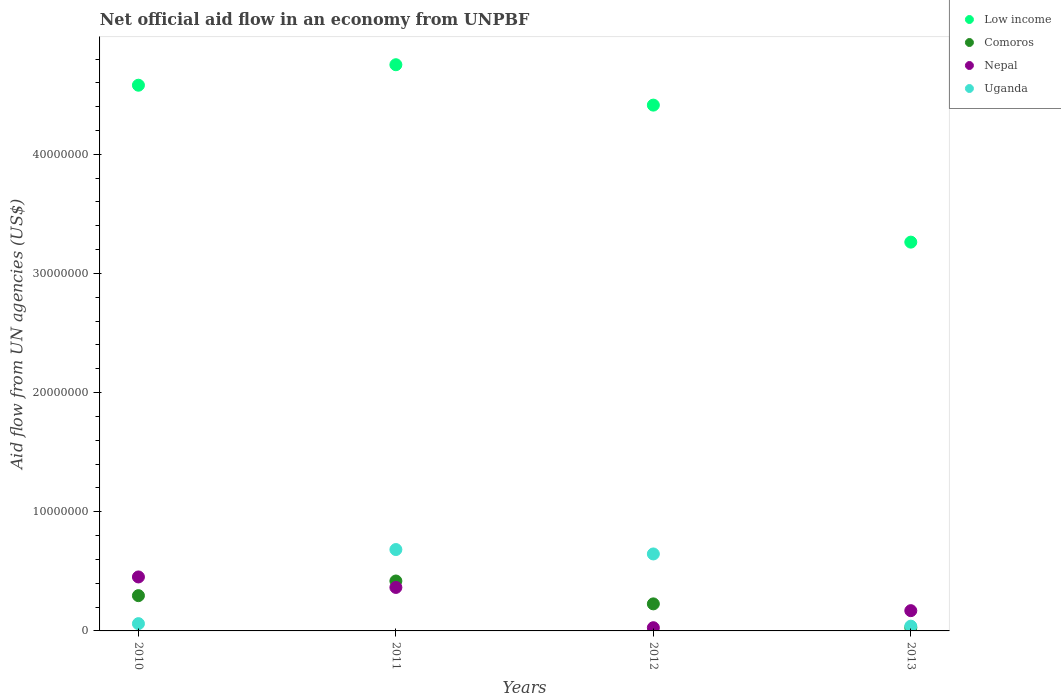What is the net official aid flow in Nepal in 2012?
Your response must be concise. 2.70e+05. Across all years, what is the maximum net official aid flow in Low income?
Provide a short and direct response. 4.75e+07. Across all years, what is the minimum net official aid flow in Comoros?
Make the answer very short. 2.70e+05. In which year was the net official aid flow in Low income maximum?
Give a very brief answer. 2011. What is the total net official aid flow in Nepal in the graph?
Make the answer very short. 1.02e+07. What is the difference between the net official aid flow in Uganda in 2012 and that in 2013?
Your answer should be very brief. 6.06e+06. What is the difference between the net official aid flow in Low income in 2013 and the net official aid flow in Comoros in 2012?
Give a very brief answer. 3.04e+07. What is the average net official aid flow in Uganda per year?
Your response must be concise. 3.58e+06. In the year 2013, what is the difference between the net official aid flow in Nepal and net official aid flow in Uganda?
Give a very brief answer. 1.30e+06. In how many years, is the net official aid flow in Nepal greater than 36000000 US$?
Your answer should be very brief. 0. What is the ratio of the net official aid flow in Comoros in 2010 to that in 2012?
Ensure brevity in your answer.  1.3. What is the difference between the highest and the second highest net official aid flow in Low income?
Offer a very short reply. 1.72e+06. What is the difference between the highest and the lowest net official aid flow in Comoros?
Keep it short and to the point. 3.92e+06. In how many years, is the net official aid flow in Uganda greater than the average net official aid flow in Uganda taken over all years?
Offer a very short reply. 2. Is the sum of the net official aid flow in Comoros in 2012 and 2013 greater than the maximum net official aid flow in Low income across all years?
Provide a succinct answer. No. Is the net official aid flow in Uganda strictly less than the net official aid flow in Comoros over the years?
Offer a very short reply. No. Does the graph contain grids?
Your answer should be compact. No. Where does the legend appear in the graph?
Your answer should be compact. Top right. How many legend labels are there?
Offer a terse response. 4. What is the title of the graph?
Provide a succinct answer. Net official aid flow in an economy from UNPBF. What is the label or title of the Y-axis?
Your answer should be compact. Aid flow from UN agencies (US$). What is the Aid flow from UN agencies (US$) of Low income in 2010?
Provide a short and direct response. 4.58e+07. What is the Aid flow from UN agencies (US$) in Comoros in 2010?
Your answer should be very brief. 2.96e+06. What is the Aid flow from UN agencies (US$) in Nepal in 2010?
Make the answer very short. 4.53e+06. What is the Aid flow from UN agencies (US$) of Low income in 2011?
Your response must be concise. 4.75e+07. What is the Aid flow from UN agencies (US$) of Comoros in 2011?
Your response must be concise. 4.19e+06. What is the Aid flow from UN agencies (US$) of Nepal in 2011?
Make the answer very short. 3.65e+06. What is the Aid flow from UN agencies (US$) of Uganda in 2011?
Provide a succinct answer. 6.83e+06. What is the Aid flow from UN agencies (US$) in Low income in 2012?
Give a very brief answer. 4.41e+07. What is the Aid flow from UN agencies (US$) in Comoros in 2012?
Your response must be concise. 2.27e+06. What is the Aid flow from UN agencies (US$) of Nepal in 2012?
Provide a succinct answer. 2.70e+05. What is the Aid flow from UN agencies (US$) of Uganda in 2012?
Offer a very short reply. 6.46e+06. What is the Aid flow from UN agencies (US$) of Low income in 2013?
Give a very brief answer. 3.26e+07. What is the Aid flow from UN agencies (US$) in Nepal in 2013?
Your answer should be compact. 1.70e+06. Across all years, what is the maximum Aid flow from UN agencies (US$) in Low income?
Offer a very short reply. 4.75e+07. Across all years, what is the maximum Aid flow from UN agencies (US$) in Comoros?
Provide a short and direct response. 4.19e+06. Across all years, what is the maximum Aid flow from UN agencies (US$) in Nepal?
Your answer should be compact. 4.53e+06. Across all years, what is the maximum Aid flow from UN agencies (US$) of Uganda?
Provide a succinct answer. 6.83e+06. Across all years, what is the minimum Aid flow from UN agencies (US$) in Low income?
Your response must be concise. 3.26e+07. Across all years, what is the minimum Aid flow from UN agencies (US$) of Uganda?
Make the answer very short. 4.00e+05. What is the total Aid flow from UN agencies (US$) of Low income in the graph?
Offer a terse response. 1.70e+08. What is the total Aid flow from UN agencies (US$) in Comoros in the graph?
Keep it short and to the point. 9.69e+06. What is the total Aid flow from UN agencies (US$) of Nepal in the graph?
Offer a very short reply. 1.02e+07. What is the total Aid flow from UN agencies (US$) of Uganda in the graph?
Your answer should be compact. 1.43e+07. What is the difference between the Aid flow from UN agencies (US$) in Low income in 2010 and that in 2011?
Ensure brevity in your answer.  -1.72e+06. What is the difference between the Aid flow from UN agencies (US$) in Comoros in 2010 and that in 2011?
Your response must be concise. -1.23e+06. What is the difference between the Aid flow from UN agencies (US$) of Nepal in 2010 and that in 2011?
Your answer should be compact. 8.80e+05. What is the difference between the Aid flow from UN agencies (US$) in Uganda in 2010 and that in 2011?
Provide a succinct answer. -6.22e+06. What is the difference between the Aid flow from UN agencies (US$) in Low income in 2010 and that in 2012?
Offer a very short reply. 1.67e+06. What is the difference between the Aid flow from UN agencies (US$) of Comoros in 2010 and that in 2012?
Provide a succinct answer. 6.90e+05. What is the difference between the Aid flow from UN agencies (US$) in Nepal in 2010 and that in 2012?
Your answer should be compact. 4.26e+06. What is the difference between the Aid flow from UN agencies (US$) of Uganda in 2010 and that in 2012?
Provide a succinct answer. -5.85e+06. What is the difference between the Aid flow from UN agencies (US$) in Low income in 2010 and that in 2013?
Keep it short and to the point. 1.32e+07. What is the difference between the Aid flow from UN agencies (US$) in Comoros in 2010 and that in 2013?
Keep it short and to the point. 2.69e+06. What is the difference between the Aid flow from UN agencies (US$) of Nepal in 2010 and that in 2013?
Make the answer very short. 2.83e+06. What is the difference between the Aid flow from UN agencies (US$) in Low income in 2011 and that in 2012?
Offer a very short reply. 3.39e+06. What is the difference between the Aid flow from UN agencies (US$) of Comoros in 2011 and that in 2012?
Offer a terse response. 1.92e+06. What is the difference between the Aid flow from UN agencies (US$) in Nepal in 2011 and that in 2012?
Give a very brief answer. 3.38e+06. What is the difference between the Aid flow from UN agencies (US$) in Uganda in 2011 and that in 2012?
Give a very brief answer. 3.70e+05. What is the difference between the Aid flow from UN agencies (US$) in Low income in 2011 and that in 2013?
Your answer should be compact. 1.49e+07. What is the difference between the Aid flow from UN agencies (US$) of Comoros in 2011 and that in 2013?
Offer a terse response. 3.92e+06. What is the difference between the Aid flow from UN agencies (US$) in Nepal in 2011 and that in 2013?
Make the answer very short. 1.95e+06. What is the difference between the Aid flow from UN agencies (US$) in Uganda in 2011 and that in 2013?
Keep it short and to the point. 6.43e+06. What is the difference between the Aid flow from UN agencies (US$) of Low income in 2012 and that in 2013?
Ensure brevity in your answer.  1.15e+07. What is the difference between the Aid flow from UN agencies (US$) of Nepal in 2012 and that in 2013?
Provide a short and direct response. -1.43e+06. What is the difference between the Aid flow from UN agencies (US$) of Uganda in 2012 and that in 2013?
Your response must be concise. 6.06e+06. What is the difference between the Aid flow from UN agencies (US$) in Low income in 2010 and the Aid flow from UN agencies (US$) in Comoros in 2011?
Your answer should be compact. 4.16e+07. What is the difference between the Aid flow from UN agencies (US$) in Low income in 2010 and the Aid flow from UN agencies (US$) in Nepal in 2011?
Provide a succinct answer. 4.22e+07. What is the difference between the Aid flow from UN agencies (US$) of Low income in 2010 and the Aid flow from UN agencies (US$) of Uganda in 2011?
Offer a terse response. 3.90e+07. What is the difference between the Aid flow from UN agencies (US$) in Comoros in 2010 and the Aid flow from UN agencies (US$) in Nepal in 2011?
Provide a succinct answer. -6.90e+05. What is the difference between the Aid flow from UN agencies (US$) in Comoros in 2010 and the Aid flow from UN agencies (US$) in Uganda in 2011?
Ensure brevity in your answer.  -3.87e+06. What is the difference between the Aid flow from UN agencies (US$) of Nepal in 2010 and the Aid flow from UN agencies (US$) of Uganda in 2011?
Your response must be concise. -2.30e+06. What is the difference between the Aid flow from UN agencies (US$) in Low income in 2010 and the Aid flow from UN agencies (US$) in Comoros in 2012?
Give a very brief answer. 4.35e+07. What is the difference between the Aid flow from UN agencies (US$) in Low income in 2010 and the Aid flow from UN agencies (US$) in Nepal in 2012?
Ensure brevity in your answer.  4.55e+07. What is the difference between the Aid flow from UN agencies (US$) of Low income in 2010 and the Aid flow from UN agencies (US$) of Uganda in 2012?
Ensure brevity in your answer.  3.93e+07. What is the difference between the Aid flow from UN agencies (US$) of Comoros in 2010 and the Aid flow from UN agencies (US$) of Nepal in 2012?
Your response must be concise. 2.69e+06. What is the difference between the Aid flow from UN agencies (US$) in Comoros in 2010 and the Aid flow from UN agencies (US$) in Uganda in 2012?
Offer a terse response. -3.50e+06. What is the difference between the Aid flow from UN agencies (US$) in Nepal in 2010 and the Aid flow from UN agencies (US$) in Uganda in 2012?
Ensure brevity in your answer.  -1.93e+06. What is the difference between the Aid flow from UN agencies (US$) of Low income in 2010 and the Aid flow from UN agencies (US$) of Comoros in 2013?
Your answer should be compact. 4.55e+07. What is the difference between the Aid flow from UN agencies (US$) of Low income in 2010 and the Aid flow from UN agencies (US$) of Nepal in 2013?
Provide a succinct answer. 4.41e+07. What is the difference between the Aid flow from UN agencies (US$) in Low income in 2010 and the Aid flow from UN agencies (US$) in Uganda in 2013?
Ensure brevity in your answer.  4.54e+07. What is the difference between the Aid flow from UN agencies (US$) in Comoros in 2010 and the Aid flow from UN agencies (US$) in Nepal in 2013?
Your response must be concise. 1.26e+06. What is the difference between the Aid flow from UN agencies (US$) of Comoros in 2010 and the Aid flow from UN agencies (US$) of Uganda in 2013?
Provide a short and direct response. 2.56e+06. What is the difference between the Aid flow from UN agencies (US$) of Nepal in 2010 and the Aid flow from UN agencies (US$) of Uganda in 2013?
Give a very brief answer. 4.13e+06. What is the difference between the Aid flow from UN agencies (US$) of Low income in 2011 and the Aid flow from UN agencies (US$) of Comoros in 2012?
Keep it short and to the point. 4.52e+07. What is the difference between the Aid flow from UN agencies (US$) in Low income in 2011 and the Aid flow from UN agencies (US$) in Nepal in 2012?
Your response must be concise. 4.72e+07. What is the difference between the Aid flow from UN agencies (US$) in Low income in 2011 and the Aid flow from UN agencies (US$) in Uganda in 2012?
Offer a terse response. 4.11e+07. What is the difference between the Aid flow from UN agencies (US$) in Comoros in 2011 and the Aid flow from UN agencies (US$) in Nepal in 2012?
Your answer should be compact. 3.92e+06. What is the difference between the Aid flow from UN agencies (US$) in Comoros in 2011 and the Aid flow from UN agencies (US$) in Uganda in 2012?
Provide a short and direct response. -2.27e+06. What is the difference between the Aid flow from UN agencies (US$) in Nepal in 2011 and the Aid flow from UN agencies (US$) in Uganda in 2012?
Offer a very short reply. -2.81e+06. What is the difference between the Aid flow from UN agencies (US$) in Low income in 2011 and the Aid flow from UN agencies (US$) in Comoros in 2013?
Offer a terse response. 4.72e+07. What is the difference between the Aid flow from UN agencies (US$) in Low income in 2011 and the Aid flow from UN agencies (US$) in Nepal in 2013?
Your answer should be compact. 4.58e+07. What is the difference between the Aid flow from UN agencies (US$) in Low income in 2011 and the Aid flow from UN agencies (US$) in Uganda in 2013?
Provide a succinct answer. 4.71e+07. What is the difference between the Aid flow from UN agencies (US$) of Comoros in 2011 and the Aid flow from UN agencies (US$) of Nepal in 2013?
Your answer should be very brief. 2.49e+06. What is the difference between the Aid flow from UN agencies (US$) of Comoros in 2011 and the Aid flow from UN agencies (US$) of Uganda in 2013?
Offer a terse response. 3.79e+06. What is the difference between the Aid flow from UN agencies (US$) in Nepal in 2011 and the Aid flow from UN agencies (US$) in Uganda in 2013?
Make the answer very short. 3.25e+06. What is the difference between the Aid flow from UN agencies (US$) in Low income in 2012 and the Aid flow from UN agencies (US$) in Comoros in 2013?
Give a very brief answer. 4.39e+07. What is the difference between the Aid flow from UN agencies (US$) of Low income in 2012 and the Aid flow from UN agencies (US$) of Nepal in 2013?
Offer a terse response. 4.24e+07. What is the difference between the Aid flow from UN agencies (US$) of Low income in 2012 and the Aid flow from UN agencies (US$) of Uganda in 2013?
Your answer should be compact. 4.37e+07. What is the difference between the Aid flow from UN agencies (US$) in Comoros in 2012 and the Aid flow from UN agencies (US$) in Nepal in 2013?
Provide a succinct answer. 5.70e+05. What is the difference between the Aid flow from UN agencies (US$) of Comoros in 2012 and the Aid flow from UN agencies (US$) of Uganda in 2013?
Offer a terse response. 1.87e+06. What is the difference between the Aid flow from UN agencies (US$) in Nepal in 2012 and the Aid flow from UN agencies (US$) in Uganda in 2013?
Give a very brief answer. -1.30e+05. What is the average Aid flow from UN agencies (US$) of Low income per year?
Keep it short and to the point. 4.25e+07. What is the average Aid flow from UN agencies (US$) in Comoros per year?
Keep it short and to the point. 2.42e+06. What is the average Aid flow from UN agencies (US$) of Nepal per year?
Your answer should be very brief. 2.54e+06. What is the average Aid flow from UN agencies (US$) of Uganda per year?
Provide a succinct answer. 3.58e+06. In the year 2010, what is the difference between the Aid flow from UN agencies (US$) of Low income and Aid flow from UN agencies (US$) of Comoros?
Provide a succinct answer. 4.28e+07. In the year 2010, what is the difference between the Aid flow from UN agencies (US$) of Low income and Aid flow from UN agencies (US$) of Nepal?
Give a very brief answer. 4.13e+07. In the year 2010, what is the difference between the Aid flow from UN agencies (US$) in Low income and Aid flow from UN agencies (US$) in Uganda?
Give a very brief answer. 4.52e+07. In the year 2010, what is the difference between the Aid flow from UN agencies (US$) of Comoros and Aid flow from UN agencies (US$) of Nepal?
Your response must be concise. -1.57e+06. In the year 2010, what is the difference between the Aid flow from UN agencies (US$) of Comoros and Aid flow from UN agencies (US$) of Uganda?
Your answer should be very brief. 2.35e+06. In the year 2010, what is the difference between the Aid flow from UN agencies (US$) of Nepal and Aid flow from UN agencies (US$) of Uganda?
Provide a succinct answer. 3.92e+06. In the year 2011, what is the difference between the Aid flow from UN agencies (US$) of Low income and Aid flow from UN agencies (US$) of Comoros?
Keep it short and to the point. 4.33e+07. In the year 2011, what is the difference between the Aid flow from UN agencies (US$) in Low income and Aid flow from UN agencies (US$) in Nepal?
Offer a very short reply. 4.39e+07. In the year 2011, what is the difference between the Aid flow from UN agencies (US$) of Low income and Aid flow from UN agencies (US$) of Uganda?
Your answer should be very brief. 4.07e+07. In the year 2011, what is the difference between the Aid flow from UN agencies (US$) in Comoros and Aid flow from UN agencies (US$) in Nepal?
Give a very brief answer. 5.40e+05. In the year 2011, what is the difference between the Aid flow from UN agencies (US$) of Comoros and Aid flow from UN agencies (US$) of Uganda?
Make the answer very short. -2.64e+06. In the year 2011, what is the difference between the Aid flow from UN agencies (US$) in Nepal and Aid flow from UN agencies (US$) in Uganda?
Provide a short and direct response. -3.18e+06. In the year 2012, what is the difference between the Aid flow from UN agencies (US$) in Low income and Aid flow from UN agencies (US$) in Comoros?
Keep it short and to the point. 4.19e+07. In the year 2012, what is the difference between the Aid flow from UN agencies (US$) in Low income and Aid flow from UN agencies (US$) in Nepal?
Keep it short and to the point. 4.39e+07. In the year 2012, what is the difference between the Aid flow from UN agencies (US$) in Low income and Aid flow from UN agencies (US$) in Uganda?
Give a very brief answer. 3.77e+07. In the year 2012, what is the difference between the Aid flow from UN agencies (US$) in Comoros and Aid flow from UN agencies (US$) in Uganda?
Ensure brevity in your answer.  -4.19e+06. In the year 2012, what is the difference between the Aid flow from UN agencies (US$) of Nepal and Aid flow from UN agencies (US$) of Uganda?
Your response must be concise. -6.19e+06. In the year 2013, what is the difference between the Aid flow from UN agencies (US$) in Low income and Aid flow from UN agencies (US$) in Comoros?
Offer a very short reply. 3.24e+07. In the year 2013, what is the difference between the Aid flow from UN agencies (US$) of Low income and Aid flow from UN agencies (US$) of Nepal?
Your answer should be compact. 3.09e+07. In the year 2013, what is the difference between the Aid flow from UN agencies (US$) in Low income and Aid flow from UN agencies (US$) in Uganda?
Ensure brevity in your answer.  3.22e+07. In the year 2013, what is the difference between the Aid flow from UN agencies (US$) in Comoros and Aid flow from UN agencies (US$) in Nepal?
Your answer should be compact. -1.43e+06. In the year 2013, what is the difference between the Aid flow from UN agencies (US$) of Nepal and Aid flow from UN agencies (US$) of Uganda?
Your response must be concise. 1.30e+06. What is the ratio of the Aid flow from UN agencies (US$) in Low income in 2010 to that in 2011?
Keep it short and to the point. 0.96. What is the ratio of the Aid flow from UN agencies (US$) of Comoros in 2010 to that in 2011?
Keep it short and to the point. 0.71. What is the ratio of the Aid flow from UN agencies (US$) in Nepal in 2010 to that in 2011?
Provide a succinct answer. 1.24. What is the ratio of the Aid flow from UN agencies (US$) in Uganda in 2010 to that in 2011?
Your answer should be very brief. 0.09. What is the ratio of the Aid flow from UN agencies (US$) in Low income in 2010 to that in 2012?
Make the answer very short. 1.04. What is the ratio of the Aid flow from UN agencies (US$) in Comoros in 2010 to that in 2012?
Provide a succinct answer. 1.3. What is the ratio of the Aid flow from UN agencies (US$) of Nepal in 2010 to that in 2012?
Provide a succinct answer. 16.78. What is the ratio of the Aid flow from UN agencies (US$) of Uganda in 2010 to that in 2012?
Your answer should be compact. 0.09. What is the ratio of the Aid flow from UN agencies (US$) of Low income in 2010 to that in 2013?
Make the answer very short. 1.4. What is the ratio of the Aid flow from UN agencies (US$) in Comoros in 2010 to that in 2013?
Your response must be concise. 10.96. What is the ratio of the Aid flow from UN agencies (US$) of Nepal in 2010 to that in 2013?
Offer a very short reply. 2.66. What is the ratio of the Aid flow from UN agencies (US$) in Uganda in 2010 to that in 2013?
Give a very brief answer. 1.52. What is the ratio of the Aid flow from UN agencies (US$) of Low income in 2011 to that in 2012?
Provide a succinct answer. 1.08. What is the ratio of the Aid flow from UN agencies (US$) in Comoros in 2011 to that in 2012?
Provide a succinct answer. 1.85. What is the ratio of the Aid flow from UN agencies (US$) of Nepal in 2011 to that in 2012?
Provide a succinct answer. 13.52. What is the ratio of the Aid flow from UN agencies (US$) of Uganda in 2011 to that in 2012?
Offer a very short reply. 1.06. What is the ratio of the Aid flow from UN agencies (US$) of Low income in 2011 to that in 2013?
Keep it short and to the point. 1.46. What is the ratio of the Aid flow from UN agencies (US$) in Comoros in 2011 to that in 2013?
Your answer should be very brief. 15.52. What is the ratio of the Aid flow from UN agencies (US$) in Nepal in 2011 to that in 2013?
Your answer should be compact. 2.15. What is the ratio of the Aid flow from UN agencies (US$) in Uganda in 2011 to that in 2013?
Provide a short and direct response. 17.07. What is the ratio of the Aid flow from UN agencies (US$) in Low income in 2012 to that in 2013?
Your answer should be very brief. 1.35. What is the ratio of the Aid flow from UN agencies (US$) in Comoros in 2012 to that in 2013?
Make the answer very short. 8.41. What is the ratio of the Aid flow from UN agencies (US$) in Nepal in 2012 to that in 2013?
Your answer should be compact. 0.16. What is the ratio of the Aid flow from UN agencies (US$) of Uganda in 2012 to that in 2013?
Offer a terse response. 16.15. What is the difference between the highest and the second highest Aid flow from UN agencies (US$) in Low income?
Make the answer very short. 1.72e+06. What is the difference between the highest and the second highest Aid flow from UN agencies (US$) of Comoros?
Your response must be concise. 1.23e+06. What is the difference between the highest and the second highest Aid flow from UN agencies (US$) in Nepal?
Ensure brevity in your answer.  8.80e+05. What is the difference between the highest and the lowest Aid flow from UN agencies (US$) in Low income?
Offer a terse response. 1.49e+07. What is the difference between the highest and the lowest Aid flow from UN agencies (US$) of Comoros?
Offer a terse response. 3.92e+06. What is the difference between the highest and the lowest Aid flow from UN agencies (US$) of Nepal?
Your answer should be compact. 4.26e+06. What is the difference between the highest and the lowest Aid flow from UN agencies (US$) in Uganda?
Offer a terse response. 6.43e+06. 